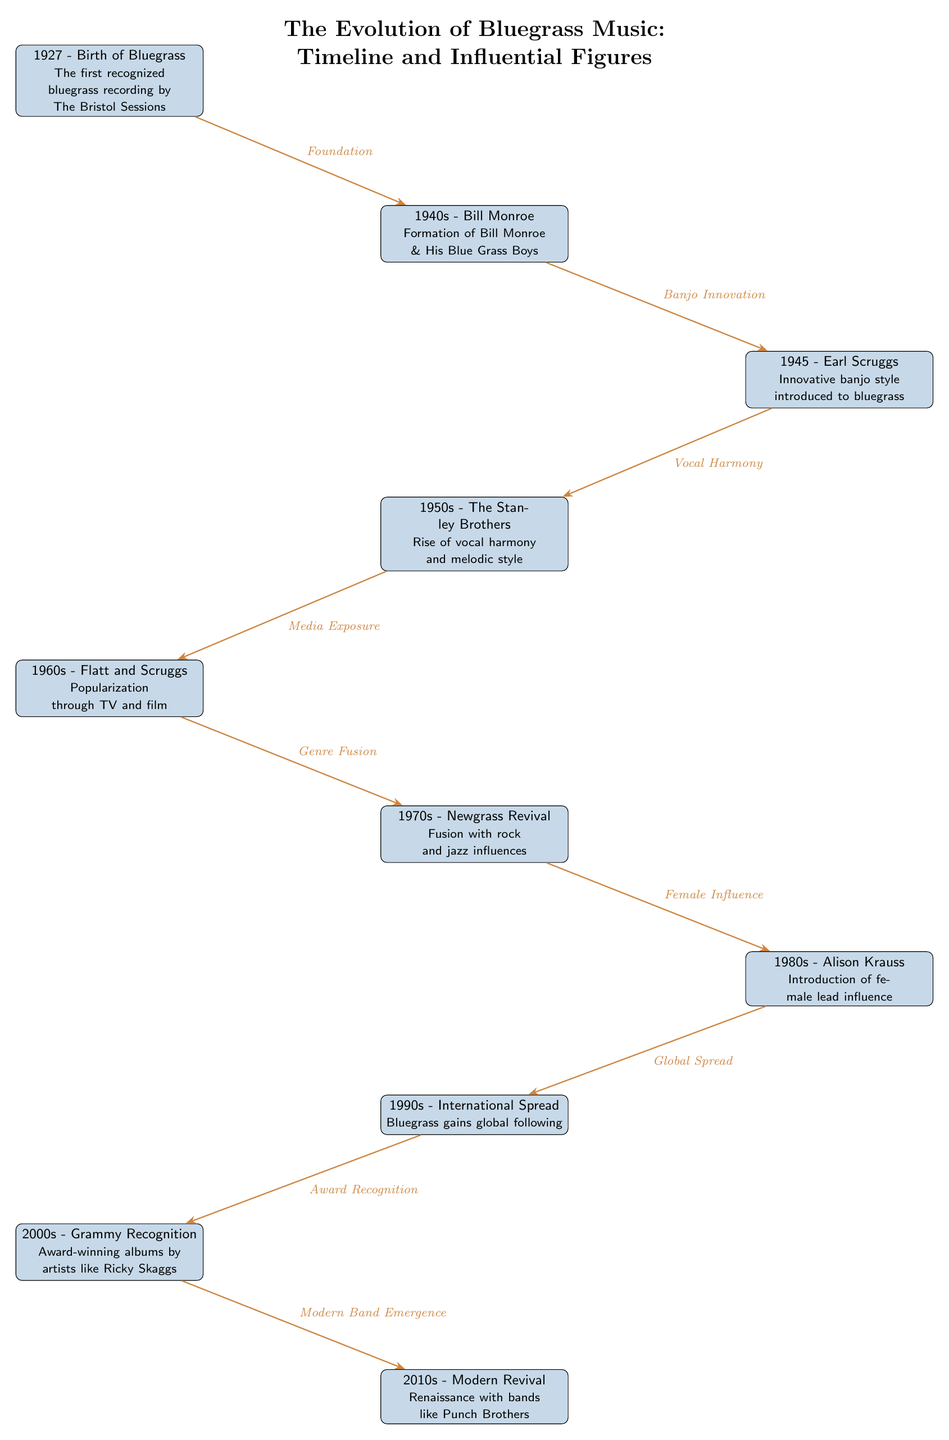What year marks the birth of bluegrass? The diagram indicates that bluegrass was born in 1927, as stated in the first node. This node specifically mentions "1927 - Birth of Bluegrass."
Answer: 1927 Who formed "Bill Monroe & His Blue Grass Boys"? The second event on the diagram, listed under the 1940s, clearly states that Bill Monroe formed "Bill Monroe & His Blue Grass Boys."
Answer: Bill Monroe What innovation did Earl Scruggs introduce in 1945? The third event states that in 1945, Earl Scruggs introduced an "Innovative banjo style," which is a key feature of his influence on bluegrass music.
Answer: Innovative banjo style Which decade is associated with the rise of vocal harmony? The diagram shows that the 1950s is the decade associated with "The Stanley Brothers," which mentions the rise of vocal harmony and melodic style.
Answer: 1950s What significant change occurred in the 1970s regarding bluegrass music? The seventh event indicates that in the 1970s, there was a "Fusion with rock and jazz influences," showcasing a significant genre evolution during that time.
Answer: Fusion with rock and jazz influences What event leads from “Global Spread” to “Award Recognition”? The diagram shows an edge labeled "Award Recognition" leading from the 1990s event "International Spread." This indicates that the global spread of bluegrass music led to greater recognition in awards.
Answer: Award Recognition How many major figures/events are included in the timeline? By counting each event node listed in the timeline, we see there are ten distinct events and influential figures noted, establishing a clear historical progression.
Answer: 10 Which artist is noted for adding female lead influence in the 1980s? The sixth event states that Alison Krauss, a significant artist, is associated with the introduction of the female lead influence in bluegrass music during the 1980s.
Answer: Alison Krauss What is the relationship between "Media Exposure" and "Modern Band Emergence"? The diagram illustrates that the "Media Exposure" event in the 1960s connects to "Modern Band Emergence" in the 2010s through previous events, indicating that media played a key role in the evolution leading to modern bands like Punch Brothers.
Answer: Media Exposure 